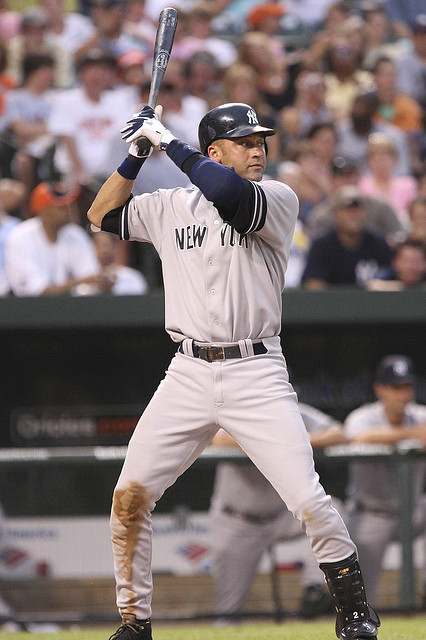Please transcribe the text information in this image. NEW NY 2 